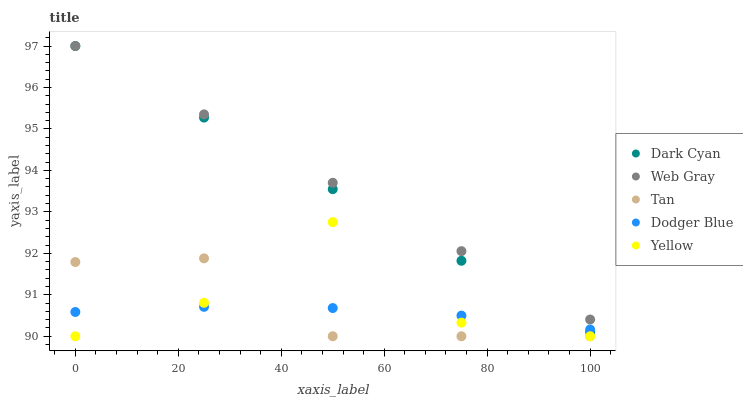Does Dodger Blue have the minimum area under the curve?
Answer yes or no. Yes. Does Web Gray have the maximum area under the curve?
Answer yes or no. Yes. Does Tan have the minimum area under the curve?
Answer yes or no. No. Does Tan have the maximum area under the curve?
Answer yes or no. No. Is Dark Cyan the smoothest?
Answer yes or no. Yes. Is Yellow the roughest?
Answer yes or no. Yes. Is Tan the smoothest?
Answer yes or no. No. Is Tan the roughest?
Answer yes or no. No. Does Tan have the lowest value?
Answer yes or no. Yes. Does Web Gray have the lowest value?
Answer yes or no. No. Does Web Gray have the highest value?
Answer yes or no. Yes. Does Tan have the highest value?
Answer yes or no. No. Is Yellow less than Web Gray?
Answer yes or no. Yes. Is Web Gray greater than Yellow?
Answer yes or no. Yes. Does Tan intersect Yellow?
Answer yes or no. Yes. Is Tan less than Yellow?
Answer yes or no. No. Is Tan greater than Yellow?
Answer yes or no. No. Does Yellow intersect Web Gray?
Answer yes or no. No. 